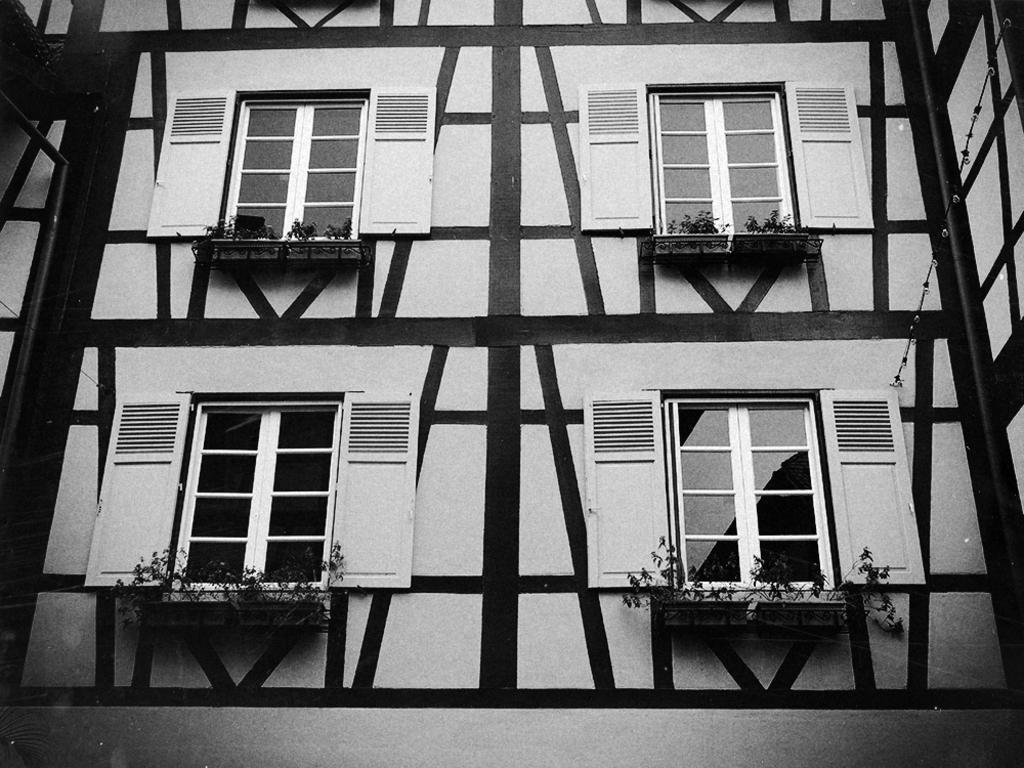Describe this image in one or two sentences. This is a black and white picture, we can see a building, there are some windows, plants and pillars. 